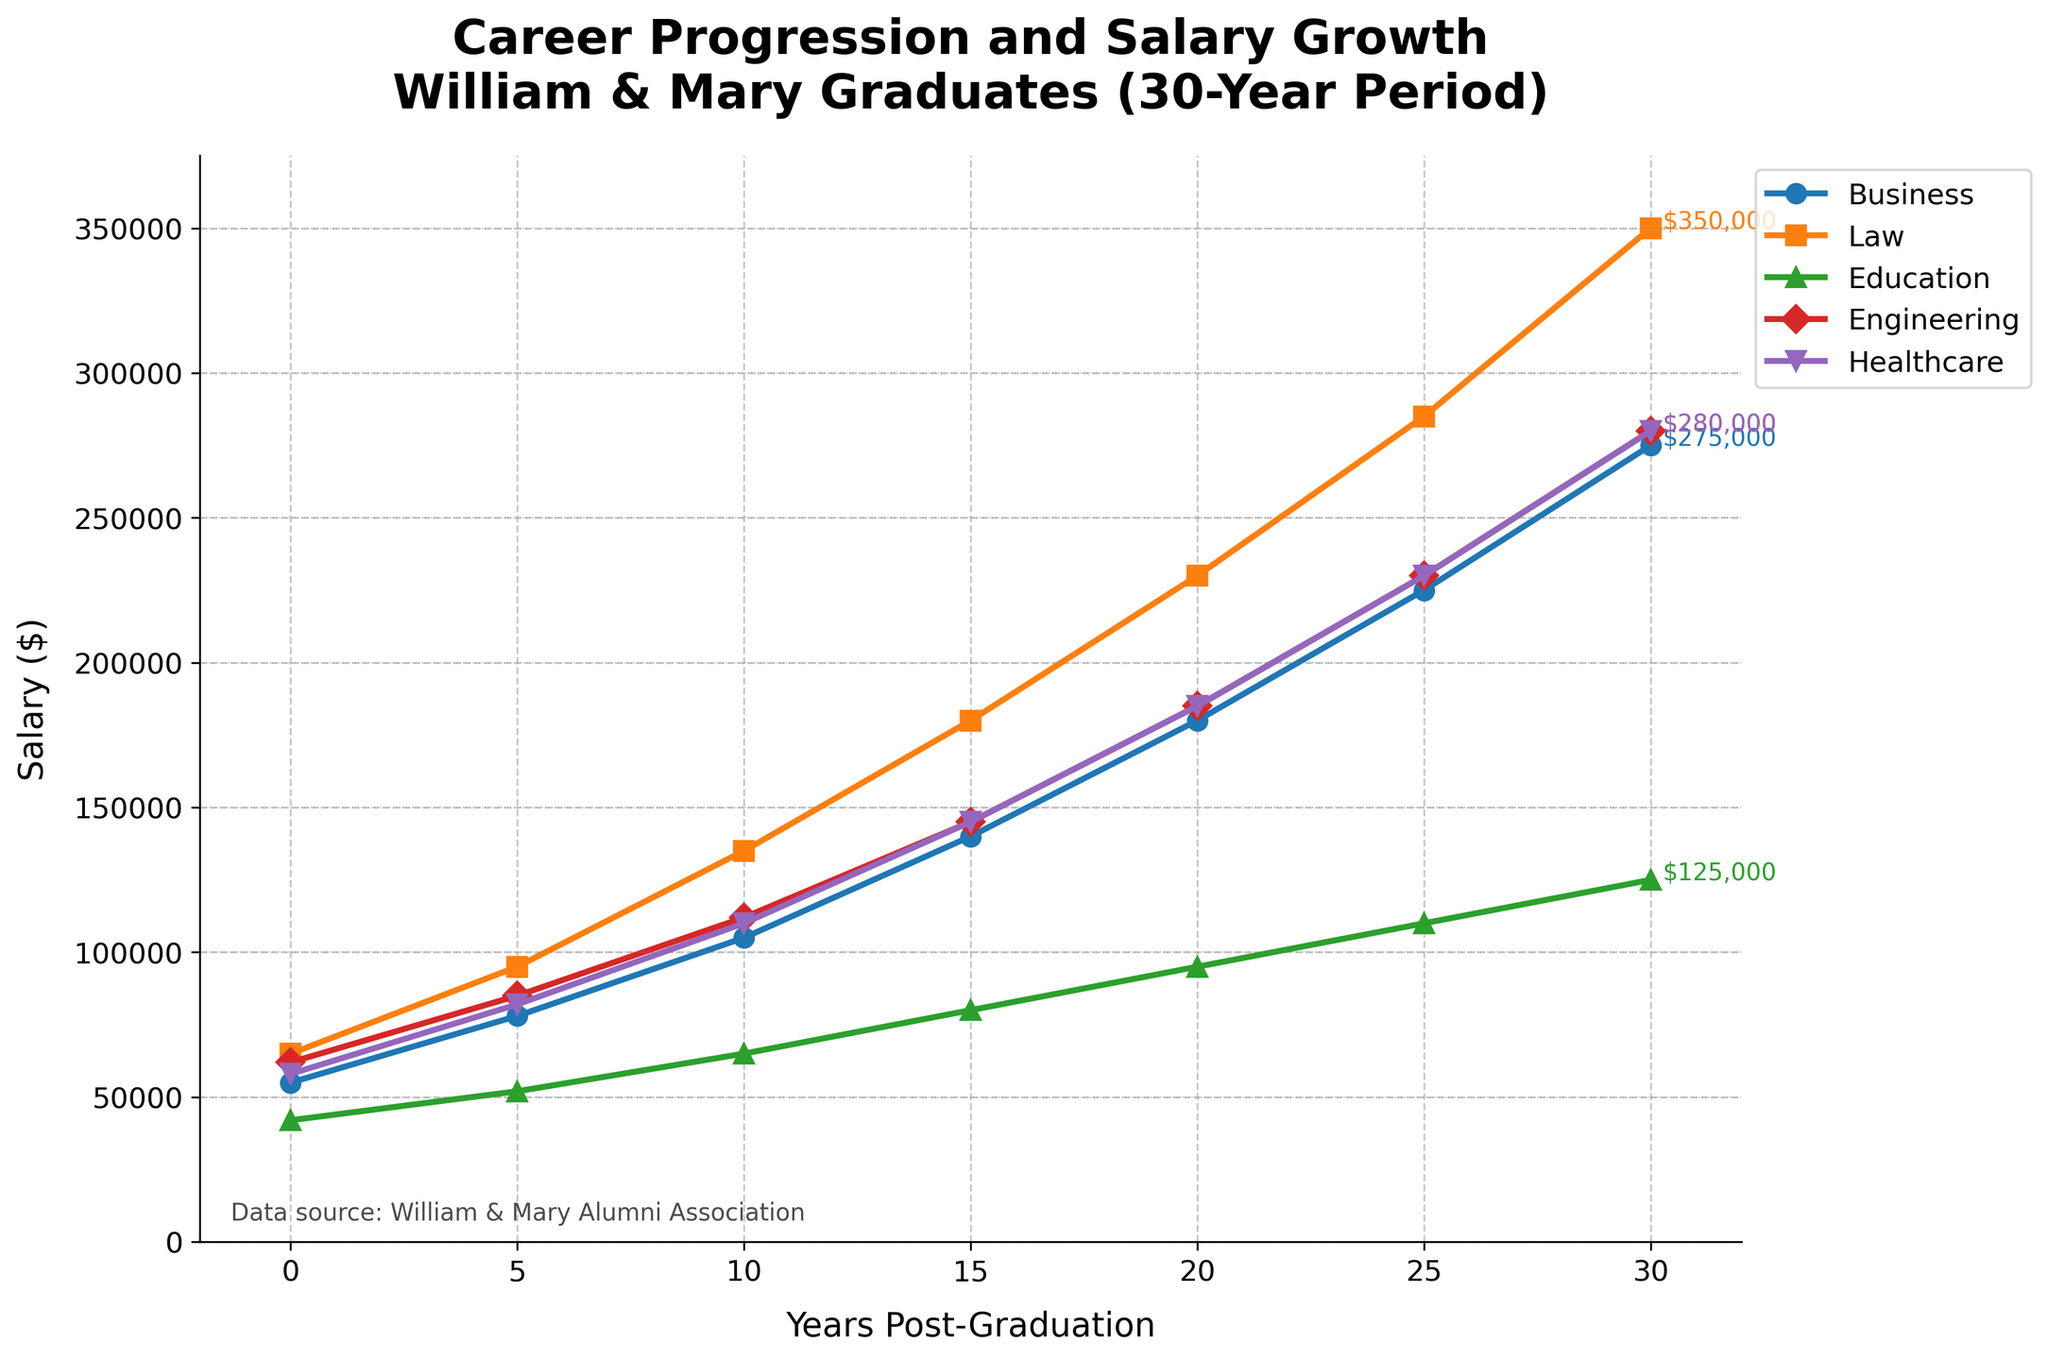Which field exhibits the highest salary at the 30-year mark? By examining the data points at the 30-year mark for each field, we find that Law has the highest salary at $350,000.
Answer: Law What is the approximate salary growth for Education graduates from 0 to 30 years post-graduation? The starting salary for Education graduates is $42,000, and it grows to $125,000 after 30 years. The growth is calculated as $125,000 - $42,000 = $83,000.
Answer: $83,000 Among Business and Engineering graduates, who has higher salary growth in the first 10 years? Business graduates start at $55,000 and reach $105,000 after 10 years, a difference of $50,000. Engineering graduates start at $62,000 and reach $112,000, a difference of $50,000 as well. Both fields have equal growth.
Answer: Equal growth Which sector shows the least growth in salary over the 30-year period? Comparing the salary growth from 0 to 30 years, Education increases from $42,000 to $125,000, which is a difference of $83,000. This is the smallest growth among all fields.
Answer: Education By how much did the salary for Healthcare professionals increase from the 5-year to the 15-year mark? The salary for Healthcare professionals is $82,000 at the 5-year mark and $145,000 at the 15-year mark. The increase is $145,000 - $82,000 = $63,000.
Answer: $63,000 What is the average salary for Law graduates over the entire 30-year period? Add all the salaries for Law ($65,000 + $95,000 + $135,000 + $180,000 + $230,000 + $285,000 + $350,000) and divide by 7. The sum is $1,340,000 and the average is $1,340,000 / 7 ≈ $191,429.
Answer: $191,429 Which field exceeds a $100,000 salary first, and in which year does this occur? By examining when each field surpasses $100,000, Business reaches $105,000 at the 10-year mark, being the first to exceed $100,000.
Answer: Business at 10 years How does the salary growth of Healthcare compare to Engineering at 25 years post-graduation? At 25 years, the salary for Healthcare is $230,000 and for Engineering it is also $230,000. Both fields have the same salary at this point.
Answer: Equal From years 15 to 30, which field's salary increases the most? Comparing the increase over this period, Business increases from $140,000 to $275,000 ($135,000), Law from $180,000 to $350,000 ($170,000), Education from $80,000 to $125,000 ($45,000), Engineering from $145,000 to $280,000 ($135,000), and Healthcare from $145,000 to $280,000 ($135,000). Law's salary increases the most.
Answer: Law What is the annual average salary increase for Business graduates over the 30-year period? To find this, take the total increase from $55,000 to $275,000 ($220,000) and divide by 30 years. $220,000 / 30 ≈ $7,333.33.
Answer: $7,333.33 